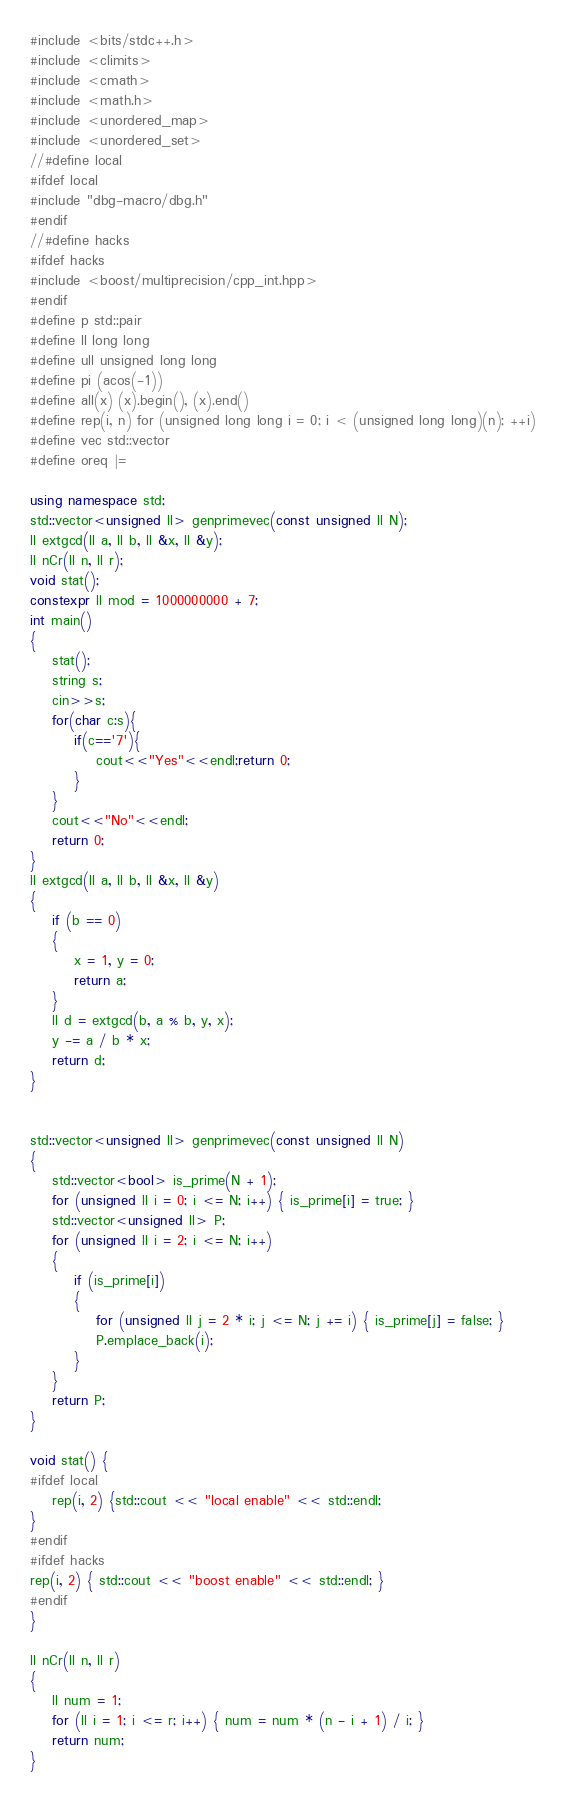<code> <loc_0><loc_0><loc_500><loc_500><_C++_>#include <bits/stdc++.h>
#include <climits>
#include <cmath>
#include <math.h>
#include <unordered_map>
#include <unordered_set>
//#define local
#ifdef local
#include "dbg-macro/dbg.h"
#endif
//#define hacks
#ifdef hacks
#include <boost/multiprecision/cpp_int.hpp>
#endif
#define p std::pair
#define ll long long
#define ull unsigned long long
#define pi (acos(-1))
#define all(x) (x).begin(), (x).end()
#define rep(i, n) for (unsigned long long i = 0; i < (unsigned long long)(n); ++i)
#define vec std::vector
#define oreq |=

using namespace std;
std::vector<unsigned ll> genprimevec(const unsigned ll N);
ll extgcd(ll a, ll b, ll &x, ll &y);
ll nCr(ll n, ll r);
void stat();
constexpr ll mod = 1000000000 + 7;
int main()
{
    stat();
    string s;
    cin>>s;
    for(char c:s){
	    if(c=='7'){
		    cout<<"Yes"<<endl;return 0;
	    }
    }
    cout<<"No"<<endl;
    return 0;
}
ll extgcd(ll a, ll b, ll &x, ll &y)
{
    if (b == 0)
    {
        x = 1, y = 0;
        return a;
    }
    ll d = extgcd(b, a % b, y, x);
    y -= a / b * x;
    return d;
}


std::vector<unsigned ll> genprimevec(const unsigned ll N)
{
    std::vector<bool> is_prime(N + 1);
    for (unsigned ll i = 0; i <= N; i++) { is_prime[i] = true; }
    std::vector<unsigned ll> P;
    for (unsigned ll i = 2; i <= N; i++)
    {
        if (is_prime[i])
        {
            for (unsigned ll j = 2 * i; j <= N; j += i) { is_prime[j] = false; }
            P.emplace_back(i);
        }
    }
    return P;
}

void stat() {
#ifdef local
    rep(i, 2) {std::cout << "local enable" << std::endl;
}
#endif
#ifdef hacks
rep(i, 2) { std::cout << "boost enable" << std::endl; }
#endif
}

ll nCr(ll n, ll r)
{
    ll num = 1;
    for (ll i = 1; i <= r; i++) { num = num * (n - i + 1) / i; }
    return num;
}
</code> 